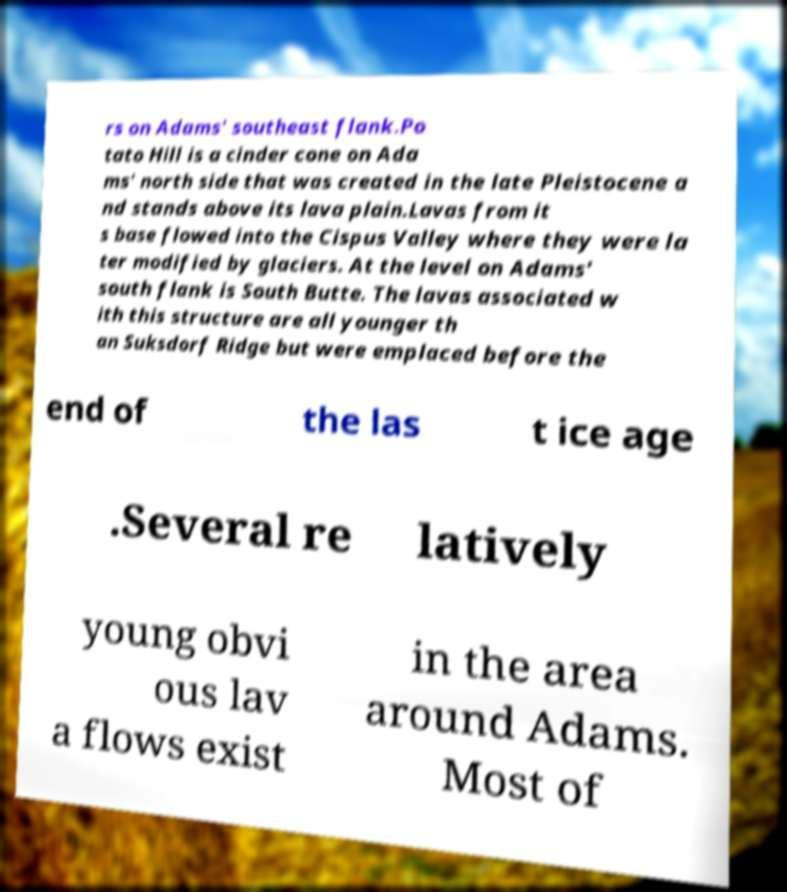I need the written content from this picture converted into text. Can you do that? rs on Adams' southeast flank.Po tato Hill is a cinder cone on Ada ms' north side that was created in the late Pleistocene a nd stands above its lava plain.Lavas from it s base flowed into the Cispus Valley where they were la ter modified by glaciers. At the level on Adams' south flank is South Butte. The lavas associated w ith this structure are all younger th an Suksdorf Ridge but were emplaced before the end of the las t ice age .Several re latively young obvi ous lav a flows exist in the area around Adams. Most of 